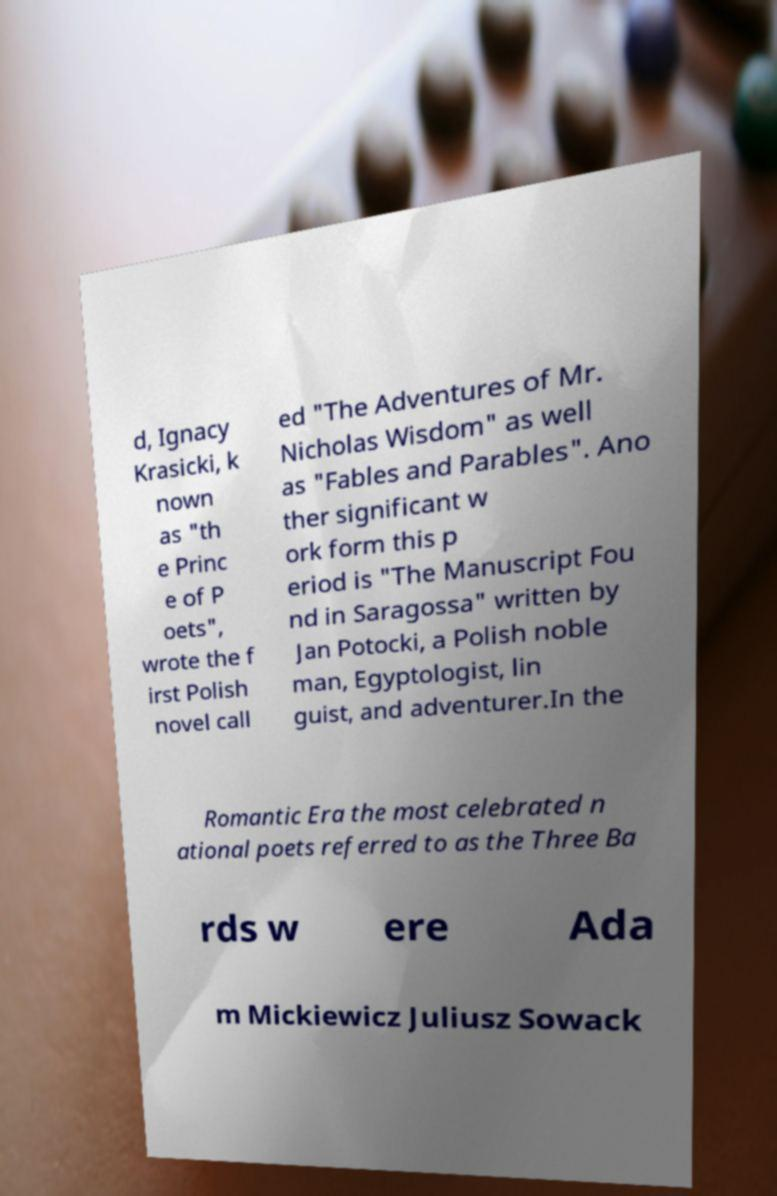Please read and relay the text visible in this image. What does it say? d, Ignacy Krasicki, k nown as "th e Princ e of P oets", wrote the f irst Polish novel call ed "The Adventures of Mr. Nicholas Wisdom" as well as "Fables and Parables". Ano ther significant w ork form this p eriod is "The Manuscript Fou nd in Saragossa" written by Jan Potocki, a Polish noble man, Egyptologist, lin guist, and adventurer.In the Romantic Era the most celebrated n ational poets referred to as the Three Ba rds w ere Ada m Mickiewicz Juliusz Sowack 